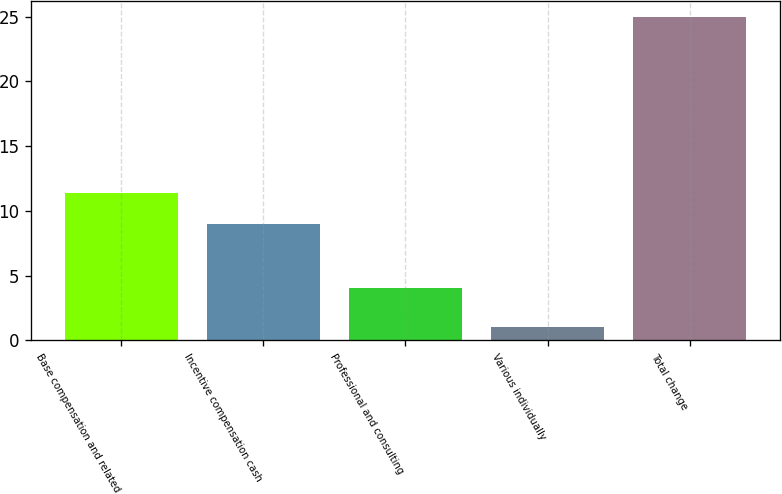Convert chart. <chart><loc_0><loc_0><loc_500><loc_500><bar_chart><fcel>Base compensation and related<fcel>Incentive compensation cash<fcel>Professional and consulting<fcel>Various individually<fcel>Total change<nl><fcel>11.4<fcel>9<fcel>4<fcel>1<fcel>25<nl></chart> 